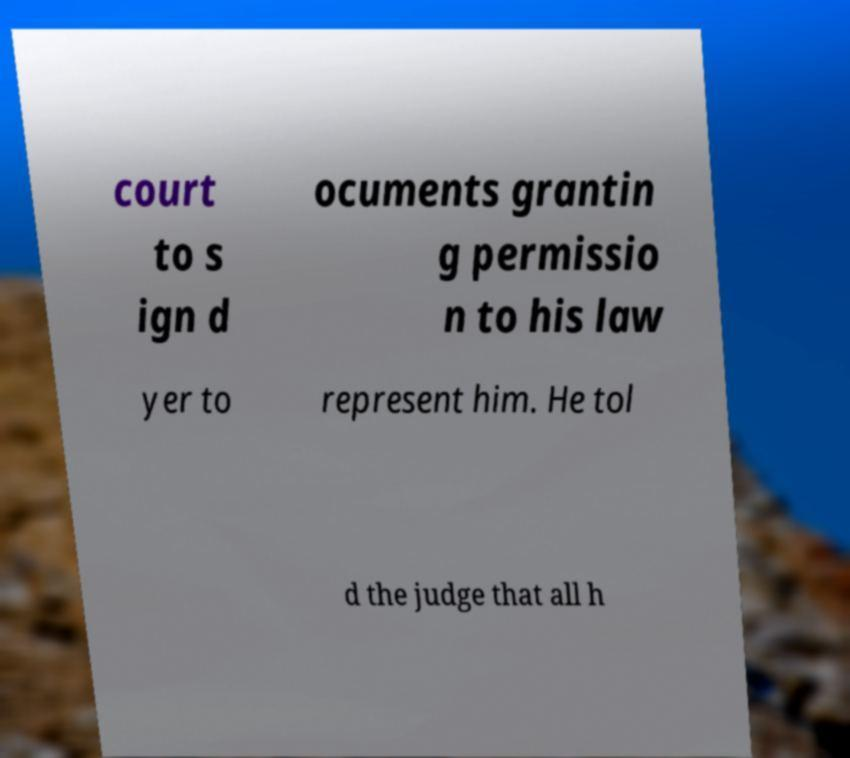What messages or text are displayed in this image? I need them in a readable, typed format. court to s ign d ocuments grantin g permissio n to his law yer to represent him. He tol d the judge that all h 